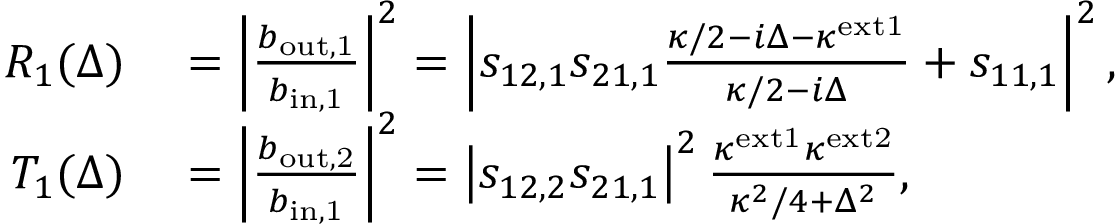Convert formula to latex. <formula><loc_0><loc_0><loc_500><loc_500>\begin{array} { r l } { R _ { 1 } ( \Delta ) } & = \left | \frac { b _ { o u t , 1 } } { b _ { i n , 1 } } \right | ^ { 2 } = \left | s _ { 1 2 , 1 } s _ { 2 1 , 1 } \frac { \kappa / 2 - i \Delta - \kappa ^ { e x t 1 } } { \kappa / 2 - i \Delta } + s _ { 1 1 , 1 } \right | ^ { 2 } , } \\ { T _ { 1 } ( \Delta ) } & = \left | \frac { b _ { o u t , 2 } } { b _ { i n , 1 } } \right | ^ { 2 } = \left | s _ { 1 2 , 2 } s _ { 2 1 , 1 } \right | ^ { 2 } \frac { \kappa ^ { e x t 1 } \kappa ^ { e x t 2 } } { \kappa ^ { 2 } / 4 + \Delta ^ { 2 } } , } \end{array}</formula> 